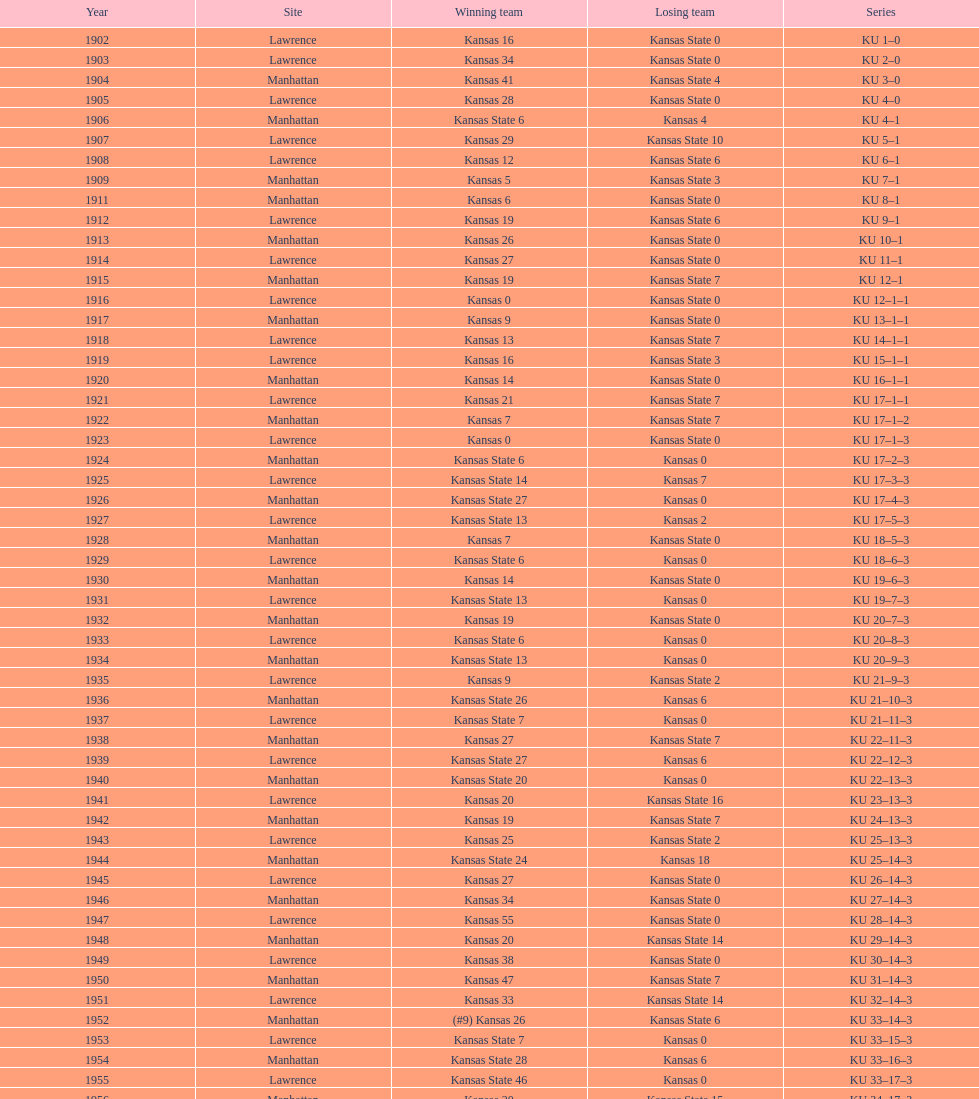What is the cumulative number of games played? 66. 